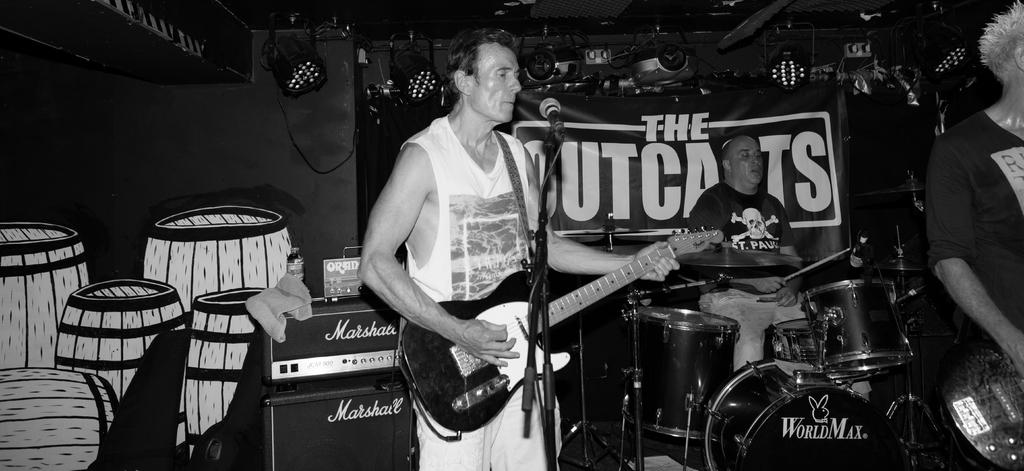What is the main activity taking place in the image? The main activity in the image is people playing musical instruments. How many people are playing musical instruments in the image? There are three people playing musical instruments in the image. What instruments are being played by the people in the image? One man is playing a guitar, another man is playing drums, and a third man is holding a guitar. What can be seen on the wall in the image? There is a poster on the wall in the image. How many fingers does the guitarist have on his left hand in the image? The image does not provide enough detail to determine the exact number of fingers the guitarist has on his left hand. Are there any giants present in the image? There are no giants present in the image; the people depicted are of normal size. 